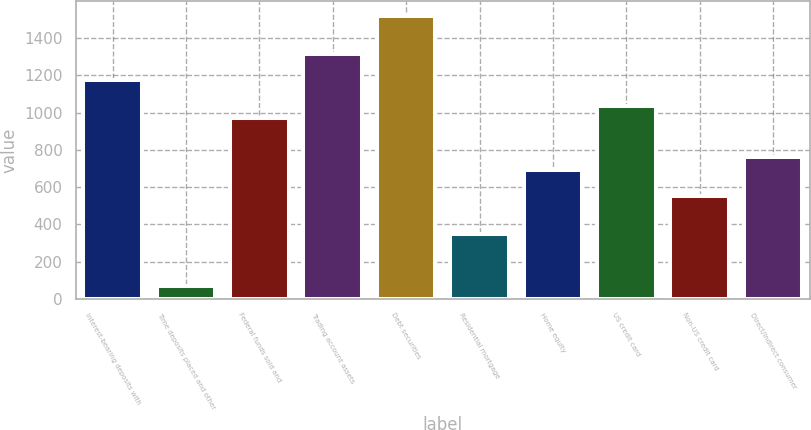Convert chart to OTSL. <chart><loc_0><loc_0><loc_500><loc_500><bar_chart><fcel>Interest-bearing deposits with<fcel>Time deposits placed and other<fcel>Federal funds sold and<fcel>Trading account assets<fcel>Debt securities<fcel>Residential mortgage<fcel>Home equity<fcel>US credit card<fcel>Non-US credit card<fcel>Direct/Indirect consumer<nl><fcel>1175.7<fcel>70.1<fcel>968.4<fcel>1313.9<fcel>1521.2<fcel>346.5<fcel>692<fcel>1037.5<fcel>553.8<fcel>761.1<nl></chart> 